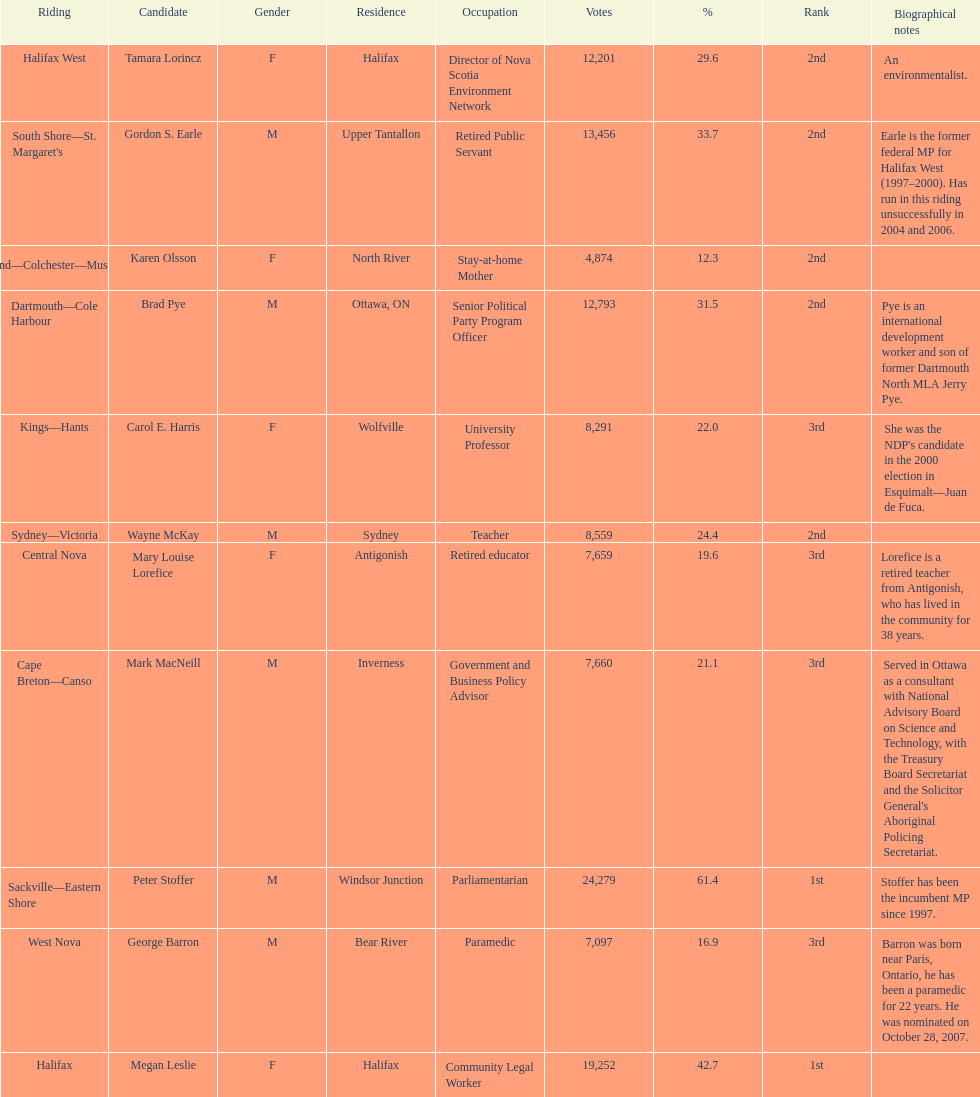What is the number of votes that megan leslie received? 19,252. 